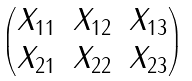<formula> <loc_0><loc_0><loc_500><loc_500>\begin{pmatrix} X _ { 1 1 } & X _ { 1 2 } & X _ { 1 3 } \\ X _ { 2 1 } & X _ { 2 2 } & X _ { 2 3 } \end{pmatrix}</formula> 